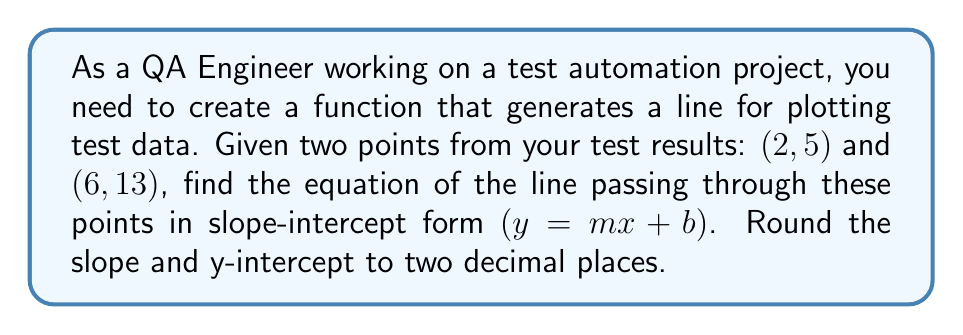Give your solution to this math problem. To find the equation of a line given two points, we'll follow these steps:

1. Calculate the slope $(m)$ using the slope formula:
   $$m = \frac{y_2 - y_1}{x_2 - x_1}$$

2. Substitute the slope and one of the points into the point-slope form of a line:
   $$y - y_1 = m(x - x_1)$$

3. Solve for $y$ to get the equation in slope-intercept form:
   $$y = mx + b$$

Let's apply these steps to our points (2, 5) and (6, 13):

1. Calculate the slope:
   $$m = \frac{13 - 5}{6 - 2} = \frac{8}{4} = 2$$

2. Use the point-slope form with (2, 5):
   $$y - 5 = 2(x - 2)$$

3. Solve for $y$:
   $$y - 5 = 2x - 4$$
   $$y = 2x - 4 + 5$$
   $$y = 2x + 1$$

Therefore, the equation of the line in slope-intercept form is $y = 2x + 1$.

The slope $(m)$ is already an integer, so no rounding is needed. The y-intercept $(b)$ is also an integer, so it doesn't need rounding either.
Answer: $y = 2x + 1$ 